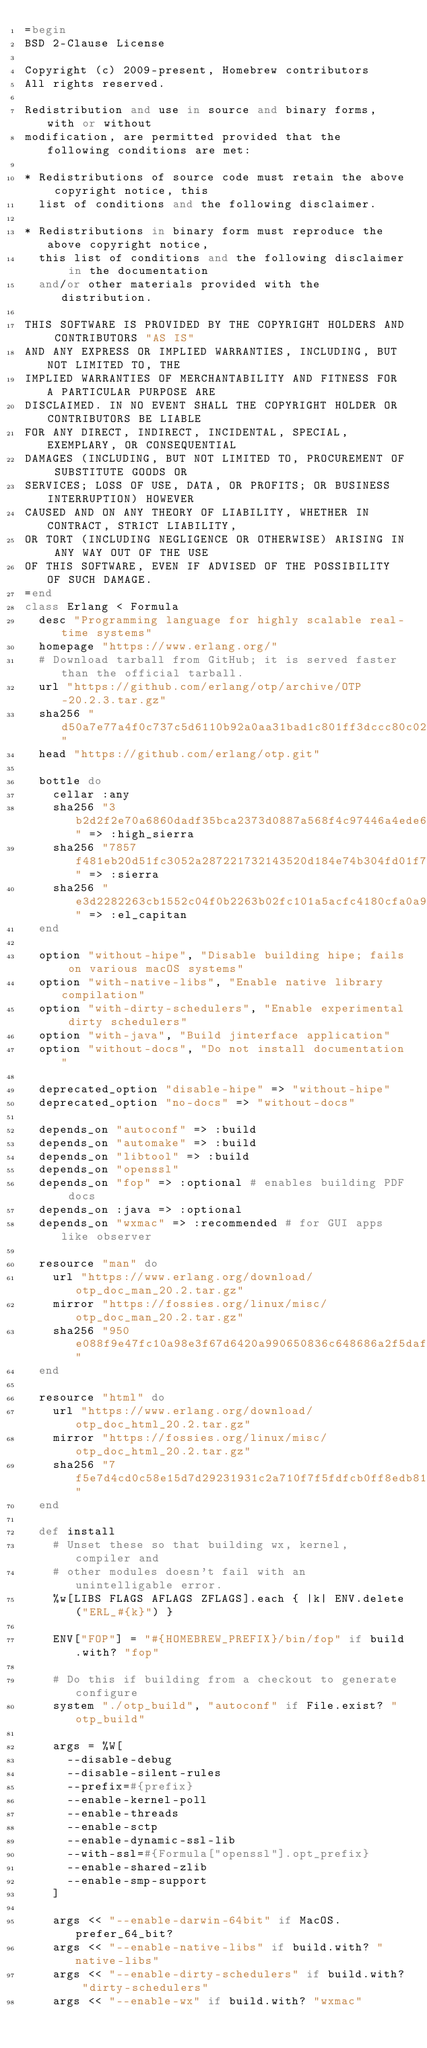<code> <loc_0><loc_0><loc_500><loc_500><_Ruby_>=begin
BSD 2-Clause License

Copyright (c) 2009-present, Homebrew contributors
All rights reserved.

Redistribution and use in source and binary forms, with or without
modification, are permitted provided that the following conditions are met:

* Redistributions of source code must retain the above copyright notice, this
  list of conditions and the following disclaimer.

* Redistributions in binary form must reproduce the above copyright notice,
  this list of conditions and the following disclaimer in the documentation
  and/or other materials provided with the distribution.

THIS SOFTWARE IS PROVIDED BY THE COPYRIGHT HOLDERS AND CONTRIBUTORS "AS IS"
AND ANY EXPRESS OR IMPLIED WARRANTIES, INCLUDING, BUT NOT LIMITED TO, THE
IMPLIED WARRANTIES OF MERCHANTABILITY AND FITNESS FOR A PARTICULAR PURPOSE ARE
DISCLAIMED. IN NO EVENT SHALL THE COPYRIGHT HOLDER OR CONTRIBUTORS BE LIABLE
FOR ANY DIRECT, INDIRECT, INCIDENTAL, SPECIAL, EXEMPLARY, OR CONSEQUENTIAL
DAMAGES (INCLUDING, BUT NOT LIMITED TO, PROCUREMENT OF SUBSTITUTE GOODS OR
SERVICES; LOSS OF USE, DATA, OR PROFITS; OR BUSINESS INTERRUPTION) HOWEVER
CAUSED AND ON ANY THEORY OF LIABILITY, WHETHER IN CONTRACT, STRICT LIABILITY,
OR TORT (INCLUDING NEGLIGENCE OR OTHERWISE) ARISING IN ANY WAY OUT OF THE USE
OF THIS SOFTWARE, EVEN IF ADVISED OF THE POSSIBILITY OF SUCH DAMAGE.
=end
class Erlang < Formula
  desc "Programming language for highly scalable real-time systems"
  homepage "https://www.erlang.org/"
  # Download tarball from GitHub; it is served faster than the official tarball.
  url "https://github.com/erlang/otp/archive/OTP-20.2.3.tar.gz"
  sha256 "d50a7e77a4f0c737c5d6110b92a0aa31bad1c801ff3dccc80c02e3d564242f69"
  head "https://github.com/erlang/otp.git"

  bottle do
    cellar :any
    sha256 "3b2d2f2e70a6860dadf35bca2373d0887a568f4c97446a4ede6dc70adcffefd7" => :high_sierra
    sha256 "7857f481eb20d51fc3052a287221732143520d184e74b304fd01f794f4e84a24" => :sierra
    sha256 "e3d2282263cb1552c04f0b2263b02fc101a5acfc4180cfa0a9056433c713031c" => :el_capitan
  end

  option "without-hipe", "Disable building hipe; fails on various macOS systems"
  option "with-native-libs", "Enable native library compilation"
  option "with-dirty-schedulers", "Enable experimental dirty schedulers"
  option "with-java", "Build jinterface application"
  option "without-docs", "Do not install documentation"

  deprecated_option "disable-hipe" => "without-hipe"
  deprecated_option "no-docs" => "without-docs"

  depends_on "autoconf" => :build
  depends_on "automake" => :build
  depends_on "libtool" => :build
  depends_on "openssl"
  depends_on "fop" => :optional # enables building PDF docs
  depends_on :java => :optional
  depends_on "wxmac" => :recommended # for GUI apps like observer

  resource "man" do
    url "https://www.erlang.org/download/otp_doc_man_20.2.tar.gz"
    mirror "https://fossies.org/linux/misc/otp_doc_man_20.2.tar.gz"
    sha256 "950e088f9e47fc10a98e3f67d6420a990650836c648686a2f5dafe331747cbdf"
  end

  resource "html" do
    url "https://www.erlang.org/download/otp_doc_html_20.2.tar.gz"
    mirror "https://fossies.org/linux/misc/otp_doc_html_20.2.tar.gz"
    sha256 "7f5e7d4cd0c58e15d7d29231931c2a710f7f5fdfcb0ff8edb8142969520c4256"
  end

  def install
    # Unset these so that building wx, kernel, compiler and
    # other modules doesn't fail with an unintelligable error.
    %w[LIBS FLAGS AFLAGS ZFLAGS].each { |k| ENV.delete("ERL_#{k}") }

    ENV["FOP"] = "#{HOMEBREW_PREFIX}/bin/fop" if build.with? "fop"

    # Do this if building from a checkout to generate configure
    system "./otp_build", "autoconf" if File.exist? "otp_build"

    args = %W[
      --disable-debug
      --disable-silent-rules
      --prefix=#{prefix}
      --enable-kernel-poll
      --enable-threads
      --enable-sctp
      --enable-dynamic-ssl-lib
      --with-ssl=#{Formula["openssl"].opt_prefix}
      --enable-shared-zlib
      --enable-smp-support
    ]

    args << "--enable-darwin-64bit" if MacOS.prefer_64_bit?
    args << "--enable-native-libs" if build.with? "native-libs"
    args << "--enable-dirty-schedulers" if build.with? "dirty-schedulers"
    args << "--enable-wx" if build.with? "wxmac"</code> 